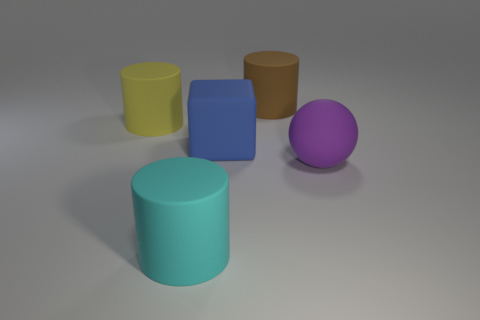How many yellow objects are behind the cyan thing?
Your answer should be very brief. 1. What is the size of the cylinder in front of the big matte thing that is on the right side of the big cylinder right of the large blue thing?
Keep it short and to the point. Large. There is a thing behind the large rubber thing that is to the left of the cyan object; is there a matte cylinder that is behind it?
Your response must be concise. No. Is the number of large blue matte cubes greater than the number of cylinders?
Offer a very short reply. No. The big object that is on the right side of the brown thing is what color?
Offer a terse response. Purple. Are there more matte cylinders on the left side of the yellow matte object than tiny gray shiny cylinders?
Offer a terse response. No. Is the material of the block the same as the brown thing?
Provide a short and direct response. Yes. What number of other objects are the same shape as the big purple object?
Make the answer very short. 0. The large rubber thing that is left of the matte object that is in front of the rubber thing right of the brown matte thing is what color?
Give a very brief answer. Yellow. Does the large matte object that is on the right side of the large brown rubber cylinder have the same shape as the blue object?
Make the answer very short. No. 